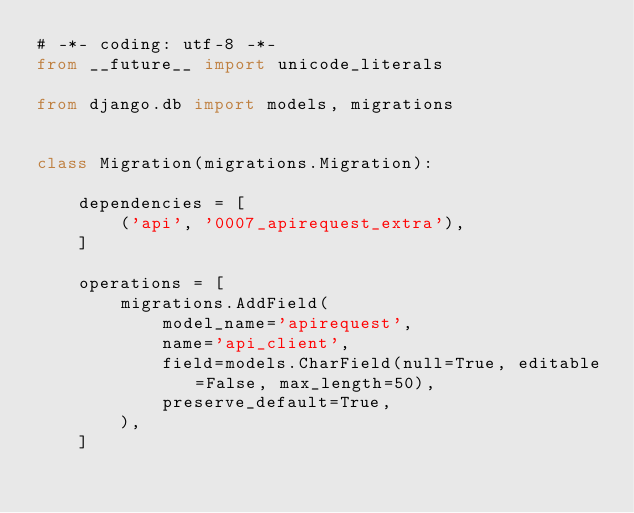Convert code to text. <code><loc_0><loc_0><loc_500><loc_500><_Python_># -*- coding: utf-8 -*-
from __future__ import unicode_literals

from django.db import models, migrations


class Migration(migrations.Migration):

    dependencies = [
        ('api', '0007_apirequest_extra'),
    ]

    operations = [
        migrations.AddField(
            model_name='apirequest',
            name='api_client',
            field=models.CharField(null=True, editable=False, max_length=50),
            preserve_default=True,
        ),
    ]
</code> 